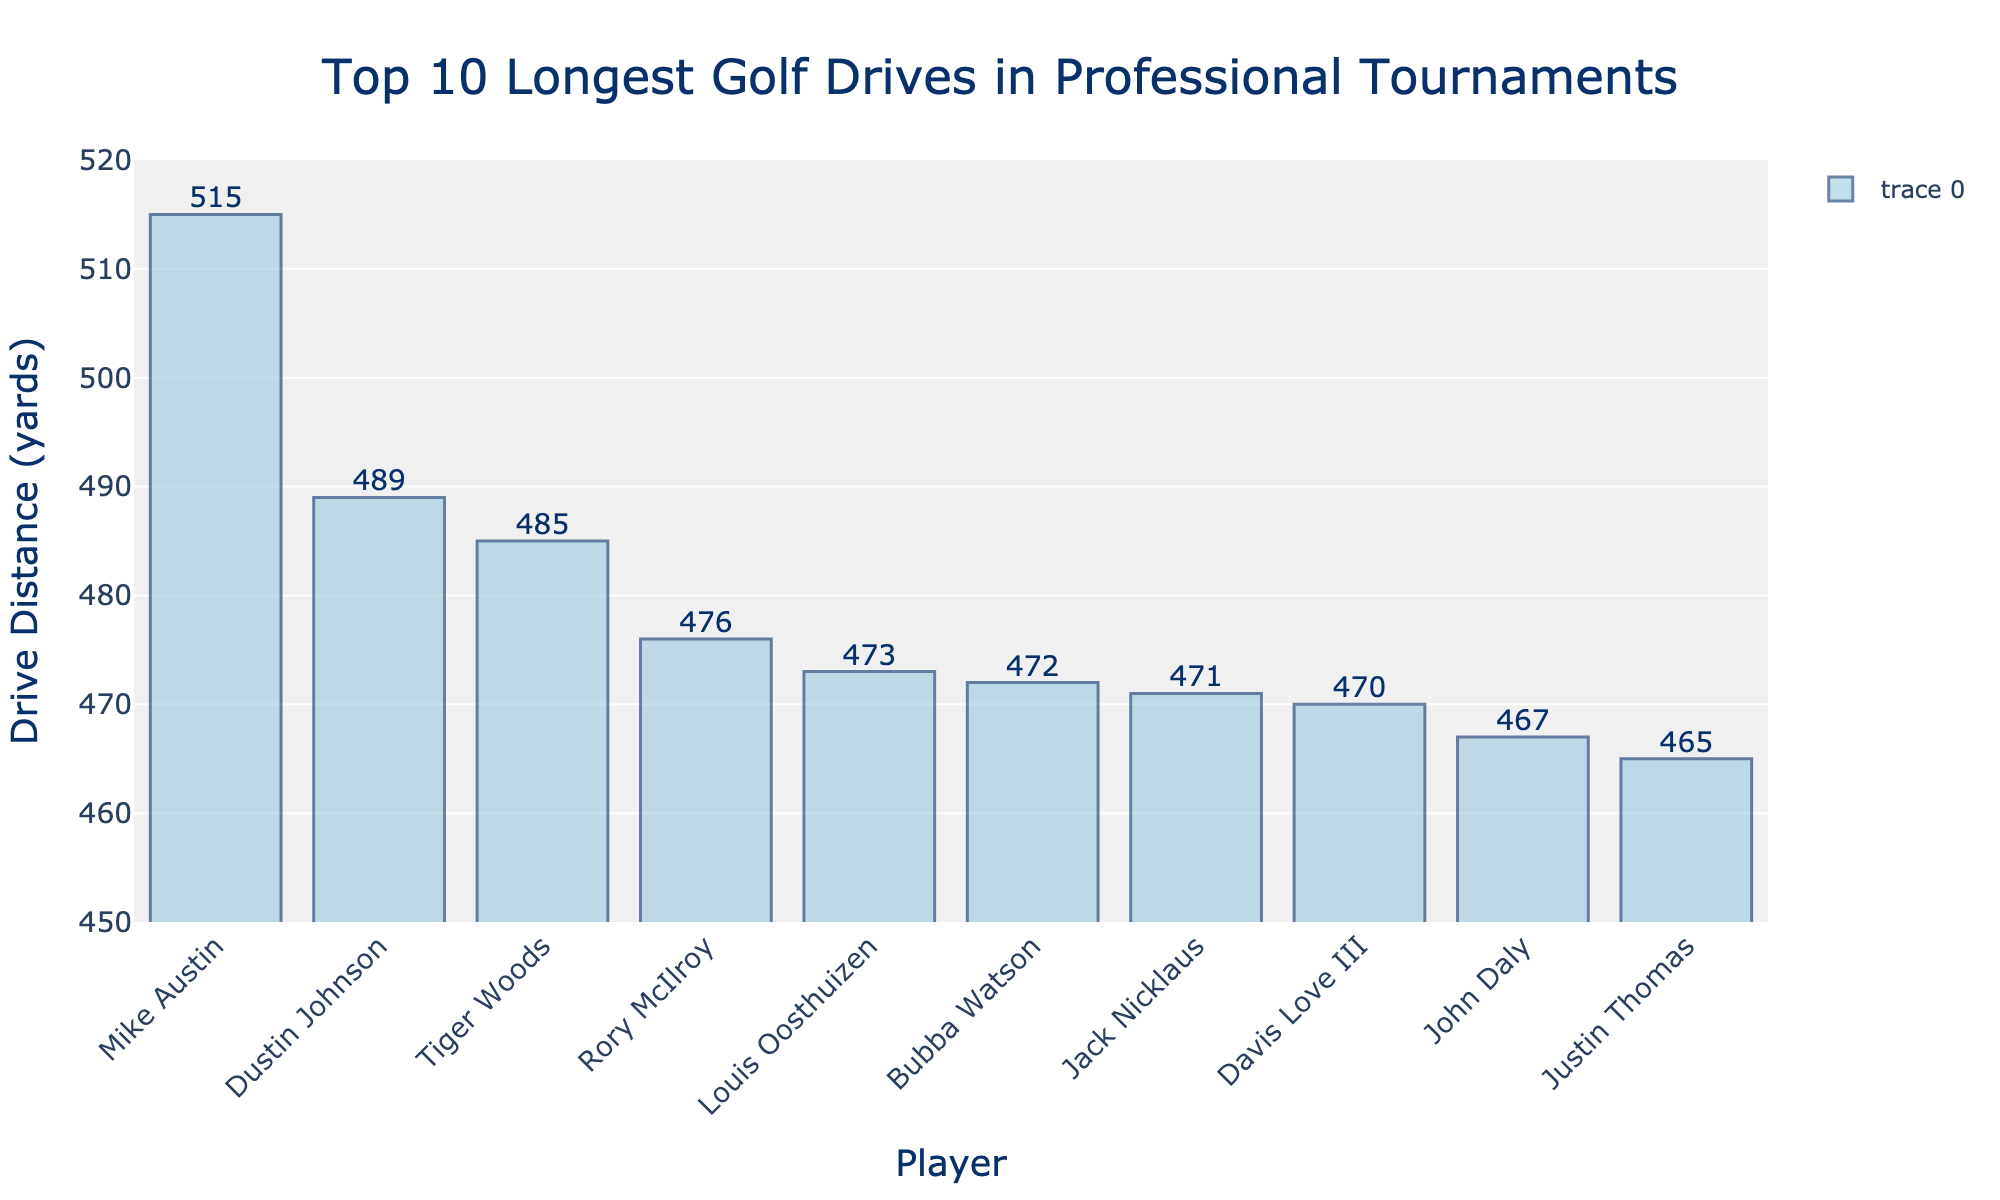Who hit the longest drive? The bar corresponding to Mike Austin is the tallest, indicating he hit the longest drive at 515 yards.
Answer: Mike Austin What is the difference in drive distance between the longest and the shortest drives? Mike Austin's drive distance is 515 yards, and Justin Thomas's distance is 465 yards. The difference is 515 - 465 = 50 yards.
Answer: 50 yards Who are the three players with the shortest drives? By observing the shortest bars and their corresponding labels, the three players with the shortest drives are Justin Thomas, John Daly, and Davis Love III.
Answer: Justin Thomas, John Daly, Davis Love III How much longer is Dustin Johnson's drive compared to Bubba Watson's? Dustin Johnson's drive is 489 yards, and Bubba Watson's drive is 472 yards. The difference is 489 - 472 = 17 yards.
Answer: 17 yards What is the average drive distance of the top 5 longest drives? The top 5 longest drives are 515, 489, 485, 476, and 473 yards. The sum is 515 + 489 + 485 + 476 + 473 = 2438 yards. The average is 2438/5 = 487.6 yards.
Answer: 487.6 yards Which player's drive is closer in distance to Rory McIlroy's drive? Rory McIlroy's drive is 476 yards. Nearby drives are 473 yards (Louis Oosthuizen) and 472 yards (Bubba Watson). Rory's drive is closer to Louis Oosthuizen's by a margin of 3 yards compared to 4 yards for Bubba Watson.
Answer: Louis Oosthuizen How many players have a drive distance greater than 470 yards? Players with more than 470 yards are Mike Austin, Dustin Johnson, Tiger Woods, Rory McIlroy, Louis Oosthuizen, Bubba Watson, and Jack Nicklaus. There are 7 such players.
Answer: 7 players What is the median drive distance? Sorting the distances in ascending order: 465, 467, 470, 471, 472, 473, 476, 485, 489, 515, the median is the middle value of this sorted list, which is 473 yards.
Answer: 473 yards Which players have drives within 5 yards of 470 yards? Drives within 5 yards of 470 yards (range 465 to 475) are Justin Thomas (465), John Daly (467), Davis Love III (470), Jack Nicklaus (471), Bubba Watson (472), Louis Oosthuizen (473).
Answer: Justin Thomas, John Daly, Davis Love III, Jack Nicklaus, Bubba Watson, Louis Oosthuizen 